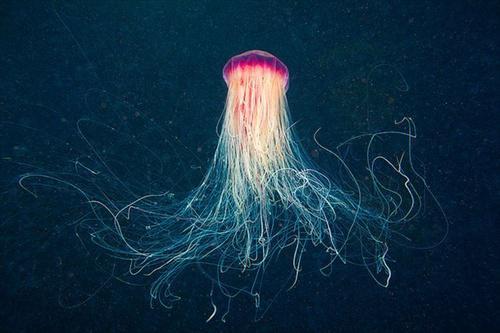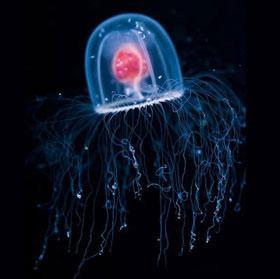The first image is the image on the left, the second image is the image on the right. Examine the images to the left and right. Is the description "There is a warm-coloured jellyfish in the right image with a darker blue almost solid water background." accurate? Answer yes or no. No. 